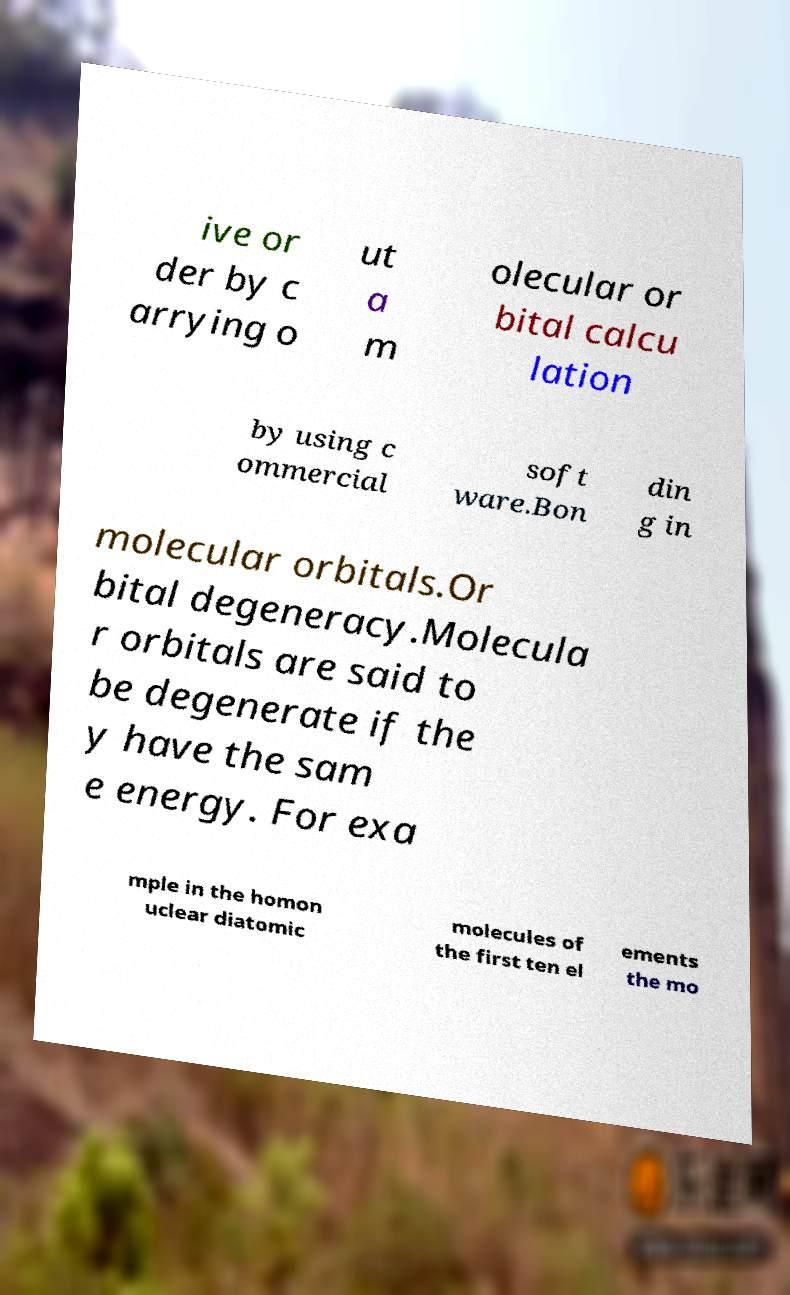Please read and relay the text visible in this image. What does it say? ive or der by c arrying o ut a m olecular or bital calcu lation by using c ommercial soft ware.Bon din g in molecular orbitals.Or bital degeneracy.Molecula r orbitals are said to be degenerate if the y have the sam e energy. For exa mple in the homon uclear diatomic molecules of the first ten el ements the mo 